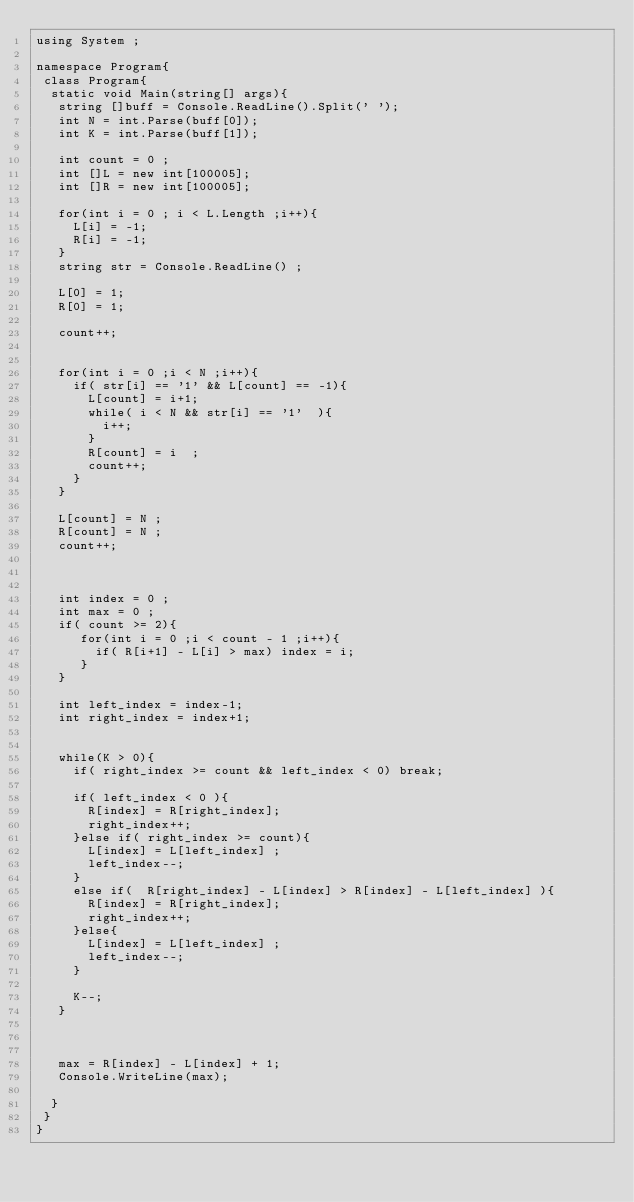Convert code to text. <code><loc_0><loc_0><loc_500><loc_500><_C#_>using System ; 
 
namespace Program{
 class Program{
  static void Main(string[] args){
   string []buff = Console.ReadLine().Split(' ');
   int N = int.Parse(buff[0]);
   int K = int.Parse(buff[1]);
   
   int count = 0 ;
   int []L = new int[100005];
   int []R = new int[100005];
   
   for(int i = 0 ; i < L.Length ;i++){
     L[i] = -1;
     R[i] = -1;
   }
   string str = Console.ReadLine() ; 
    
   L[0] = 1;
   R[0] = 1;
    
   count++;
    
 
   for(int i = 0 ;i < N ;i++){
     if( str[i] == '1' && L[count] == -1){
       L[count] = i+1; 
       while( i < N && str[i] == '1'  ){
         i++; 
       }
       R[count] = i  ;
       count++;
     }
   }
   
   L[count] = N ;
   R[count] = N ;
   count++;
    
 
    
   int index = 0 ;
   int max = 0 ;
   if( count >= 2){
      for(int i = 0 ;i < count - 1 ;i++){
        if( R[i+1] - L[i] > max) index = i;
      }
   }
    
   int left_index = index-1;
   int right_index = index+1;
   
    
   while(K > 0){
     if( right_index >= count && left_index < 0) break;
     
     if( left_index < 0 ){
       R[index] = R[right_index];
       right_index++;
     }else if( right_index >= count){
       L[index] = L[left_index] ;
       left_index--;
     }
     else if(  R[right_index] - L[index] > R[index] - L[left_index] ){
       R[index] = R[right_index];
       right_index++;
     }else{
       L[index] = L[left_index] ;
       left_index--;
     }
 
     K--;
   }
   
 
 
   max = R[index] - L[index] + 1;
   Console.WriteLine(max);
    
  }
 }
}</code> 